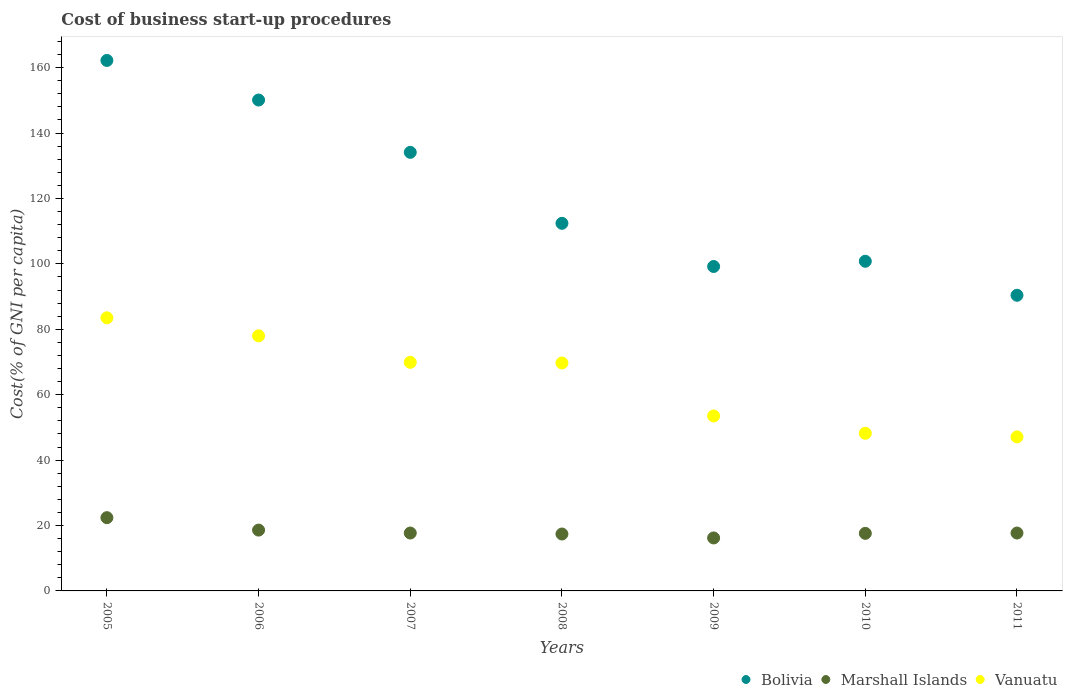Is the number of dotlines equal to the number of legend labels?
Make the answer very short. Yes. What is the cost of business start-up procedures in Bolivia in 2006?
Make the answer very short. 150.1. Across all years, what is the maximum cost of business start-up procedures in Marshall Islands?
Keep it short and to the point. 22.4. Across all years, what is the minimum cost of business start-up procedures in Vanuatu?
Provide a succinct answer. 47.1. What is the total cost of business start-up procedures in Bolivia in the graph?
Offer a very short reply. 849.2. What is the difference between the cost of business start-up procedures in Marshall Islands in 2007 and that in 2010?
Make the answer very short. 0.1. What is the difference between the cost of business start-up procedures in Marshall Islands in 2007 and the cost of business start-up procedures in Vanuatu in 2008?
Provide a short and direct response. -52. What is the average cost of business start-up procedures in Bolivia per year?
Your answer should be compact. 121.31. In the year 2007, what is the difference between the cost of business start-up procedures in Vanuatu and cost of business start-up procedures in Marshall Islands?
Offer a very short reply. 52.2. What is the ratio of the cost of business start-up procedures in Bolivia in 2010 to that in 2011?
Your answer should be compact. 1.12. What is the difference between the highest and the lowest cost of business start-up procedures in Marshall Islands?
Ensure brevity in your answer.  6.2. In how many years, is the cost of business start-up procedures in Vanuatu greater than the average cost of business start-up procedures in Vanuatu taken over all years?
Keep it short and to the point. 4. Is the sum of the cost of business start-up procedures in Marshall Islands in 2005 and 2008 greater than the maximum cost of business start-up procedures in Vanuatu across all years?
Your answer should be very brief. No. Does the cost of business start-up procedures in Marshall Islands monotonically increase over the years?
Give a very brief answer. No. Is the cost of business start-up procedures in Marshall Islands strictly greater than the cost of business start-up procedures in Vanuatu over the years?
Make the answer very short. No. Is the cost of business start-up procedures in Marshall Islands strictly less than the cost of business start-up procedures in Vanuatu over the years?
Offer a terse response. Yes. How many years are there in the graph?
Make the answer very short. 7. Are the values on the major ticks of Y-axis written in scientific E-notation?
Your answer should be compact. No. Does the graph contain grids?
Offer a terse response. No. Where does the legend appear in the graph?
Offer a very short reply. Bottom right. What is the title of the graph?
Offer a terse response. Cost of business start-up procedures. Does "Belarus" appear as one of the legend labels in the graph?
Keep it short and to the point. No. What is the label or title of the Y-axis?
Your response must be concise. Cost(% of GNI per capita). What is the Cost(% of GNI per capita) in Bolivia in 2005?
Ensure brevity in your answer.  162.2. What is the Cost(% of GNI per capita) in Marshall Islands in 2005?
Offer a very short reply. 22.4. What is the Cost(% of GNI per capita) in Vanuatu in 2005?
Ensure brevity in your answer.  83.5. What is the Cost(% of GNI per capita) of Bolivia in 2006?
Give a very brief answer. 150.1. What is the Cost(% of GNI per capita) of Marshall Islands in 2006?
Your answer should be very brief. 18.6. What is the Cost(% of GNI per capita) of Bolivia in 2007?
Give a very brief answer. 134.1. What is the Cost(% of GNI per capita) in Vanuatu in 2007?
Offer a very short reply. 69.9. What is the Cost(% of GNI per capita) of Bolivia in 2008?
Give a very brief answer. 112.4. What is the Cost(% of GNI per capita) in Marshall Islands in 2008?
Your answer should be compact. 17.4. What is the Cost(% of GNI per capita) in Vanuatu in 2008?
Ensure brevity in your answer.  69.7. What is the Cost(% of GNI per capita) of Bolivia in 2009?
Provide a succinct answer. 99.2. What is the Cost(% of GNI per capita) of Vanuatu in 2009?
Offer a very short reply. 53.5. What is the Cost(% of GNI per capita) in Bolivia in 2010?
Provide a short and direct response. 100.8. What is the Cost(% of GNI per capita) in Marshall Islands in 2010?
Make the answer very short. 17.6. What is the Cost(% of GNI per capita) in Vanuatu in 2010?
Offer a very short reply. 48.2. What is the Cost(% of GNI per capita) in Bolivia in 2011?
Keep it short and to the point. 90.4. What is the Cost(% of GNI per capita) of Vanuatu in 2011?
Offer a very short reply. 47.1. Across all years, what is the maximum Cost(% of GNI per capita) in Bolivia?
Give a very brief answer. 162.2. Across all years, what is the maximum Cost(% of GNI per capita) in Marshall Islands?
Give a very brief answer. 22.4. Across all years, what is the maximum Cost(% of GNI per capita) of Vanuatu?
Keep it short and to the point. 83.5. Across all years, what is the minimum Cost(% of GNI per capita) in Bolivia?
Provide a succinct answer. 90.4. Across all years, what is the minimum Cost(% of GNI per capita) of Marshall Islands?
Keep it short and to the point. 16.2. Across all years, what is the minimum Cost(% of GNI per capita) in Vanuatu?
Your answer should be very brief. 47.1. What is the total Cost(% of GNI per capita) of Bolivia in the graph?
Offer a very short reply. 849.2. What is the total Cost(% of GNI per capita) of Marshall Islands in the graph?
Your answer should be compact. 127.6. What is the total Cost(% of GNI per capita) of Vanuatu in the graph?
Ensure brevity in your answer.  449.9. What is the difference between the Cost(% of GNI per capita) in Bolivia in 2005 and that in 2006?
Give a very brief answer. 12.1. What is the difference between the Cost(% of GNI per capita) of Marshall Islands in 2005 and that in 2006?
Provide a short and direct response. 3.8. What is the difference between the Cost(% of GNI per capita) of Bolivia in 2005 and that in 2007?
Keep it short and to the point. 28.1. What is the difference between the Cost(% of GNI per capita) of Bolivia in 2005 and that in 2008?
Provide a short and direct response. 49.8. What is the difference between the Cost(% of GNI per capita) of Marshall Islands in 2005 and that in 2008?
Provide a succinct answer. 5. What is the difference between the Cost(% of GNI per capita) in Bolivia in 2005 and that in 2010?
Provide a succinct answer. 61.4. What is the difference between the Cost(% of GNI per capita) in Marshall Islands in 2005 and that in 2010?
Offer a very short reply. 4.8. What is the difference between the Cost(% of GNI per capita) of Vanuatu in 2005 and that in 2010?
Keep it short and to the point. 35.3. What is the difference between the Cost(% of GNI per capita) in Bolivia in 2005 and that in 2011?
Offer a very short reply. 71.8. What is the difference between the Cost(% of GNI per capita) in Marshall Islands in 2005 and that in 2011?
Your answer should be compact. 4.7. What is the difference between the Cost(% of GNI per capita) in Vanuatu in 2005 and that in 2011?
Give a very brief answer. 36.4. What is the difference between the Cost(% of GNI per capita) in Bolivia in 2006 and that in 2007?
Provide a succinct answer. 16. What is the difference between the Cost(% of GNI per capita) in Vanuatu in 2006 and that in 2007?
Your answer should be very brief. 8.1. What is the difference between the Cost(% of GNI per capita) of Bolivia in 2006 and that in 2008?
Ensure brevity in your answer.  37.7. What is the difference between the Cost(% of GNI per capita) in Marshall Islands in 2006 and that in 2008?
Make the answer very short. 1.2. What is the difference between the Cost(% of GNI per capita) in Bolivia in 2006 and that in 2009?
Offer a terse response. 50.9. What is the difference between the Cost(% of GNI per capita) of Bolivia in 2006 and that in 2010?
Ensure brevity in your answer.  49.3. What is the difference between the Cost(% of GNI per capita) in Marshall Islands in 2006 and that in 2010?
Make the answer very short. 1. What is the difference between the Cost(% of GNI per capita) in Vanuatu in 2006 and that in 2010?
Your response must be concise. 29.8. What is the difference between the Cost(% of GNI per capita) in Bolivia in 2006 and that in 2011?
Your response must be concise. 59.7. What is the difference between the Cost(% of GNI per capita) of Marshall Islands in 2006 and that in 2011?
Make the answer very short. 0.9. What is the difference between the Cost(% of GNI per capita) in Vanuatu in 2006 and that in 2011?
Offer a terse response. 30.9. What is the difference between the Cost(% of GNI per capita) of Bolivia in 2007 and that in 2008?
Provide a short and direct response. 21.7. What is the difference between the Cost(% of GNI per capita) of Marshall Islands in 2007 and that in 2008?
Give a very brief answer. 0.3. What is the difference between the Cost(% of GNI per capita) of Vanuatu in 2007 and that in 2008?
Offer a very short reply. 0.2. What is the difference between the Cost(% of GNI per capita) in Bolivia in 2007 and that in 2009?
Offer a terse response. 34.9. What is the difference between the Cost(% of GNI per capita) of Bolivia in 2007 and that in 2010?
Offer a terse response. 33.3. What is the difference between the Cost(% of GNI per capita) of Vanuatu in 2007 and that in 2010?
Make the answer very short. 21.7. What is the difference between the Cost(% of GNI per capita) in Bolivia in 2007 and that in 2011?
Keep it short and to the point. 43.7. What is the difference between the Cost(% of GNI per capita) in Vanuatu in 2007 and that in 2011?
Your answer should be very brief. 22.8. What is the difference between the Cost(% of GNI per capita) of Bolivia in 2008 and that in 2009?
Offer a terse response. 13.2. What is the difference between the Cost(% of GNI per capita) of Vanuatu in 2008 and that in 2010?
Your answer should be compact. 21.5. What is the difference between the Cost(% of GNI per capita) in Bolivia in 2008 and that in 2011?
Your response must be concise. 22. What is the difference between the Cost(% of GNI per capita) of Marshall Islands in 2008 and that in 2011?
Your answer should be compact. -0.3. What is the difference between the Cost(% of GNI per capita) in Vanuatu in 2008 and that in 2011?
Offer a terse response. 22.6. What is the difference between the Cost(% of GNI per capita) of Bolivia in 2009 and that in 2010?
Provide a succinct answer. -1.6. What is the difference between the Cost(% of GNI per capita) in Marshall Islands in 2009 and that in 2010?
Give a very brief answer. -1.4. What is the difference between the Cost(% of GNI per capita) in Vanuatu in 2009 and that in 2010?
Provide a short and direct response. 5.3. What is the difference between the Cost(% of GNI per capita) in Marshall Islands in 2009 and that in 2011?
Ensure brevity in your answer.  -1.5. What is the difference between the Cost(% of GNI per capita) of Vanuatu in 2009 and that in 2011?
Keep it short and to the point. 6.4. What is the difference between the Cost(% of GNI per capita) in Marshall Islands in 2010 and that in 2011?
Make the answer very short. -0.1. What is the difference between the Cost(% of GNI per capita) of Vanuatu in 2010 and that in 2011?
Your response must be concise. 1.1. What is the difference between the Cost(% of GNI per capita) in Bolivia in 2005 and the Cost(% of GNI per capita) in Marshall Islands in 2006?
Your answer should be compact. 143.6. What is the difference between the Cost(% of GNI per capita) in Bolivia in 2005 and the Cost(% of GNI per capita) in Vanuatu in 2006?
Your response must be concise. 84.2. What is the difference between the Cost(% of GNI per capita) in Marshall Islands in 2005 and the Cost(% of GNI per capita) in Vanuatu in 2006?
Ensure brevity in your answer.  -55.6. What is the difference between the Cost(% of GNI per capita) of Bolivia in 2005 and the Cost(% of GNI per capita) of Marshall Islands in 2007?
Your answer should be compact. 144.5. What is the difference between the Cost(% of GNI per capita) in Bolivia in 2005 and the Cost(% of GNI per capita) in Vanuatu in 2007?
Give a very brief answer. 92.3. What is the difference between the Cost(% of GNI per capita) of Marshall Islands in 2005 and the Cost(% of GNI per capita) of Vanuatu in 2007?
Your response must be concise. -47.5. What is the difference between the Cost(% of GNI per capita) in Bolivia in 2005 and the Cost(% of GNI per capita) in Marshall Islands in 2008?
Keep it short and to the point. 144.8. What is the difference between the Cost(% of GNI per capita) of Bolivia in 2005 and the Cost(% of GNI per capita) of Vanuatu in 2008?
Offer a terse response. 92.5. What is the difference between the Cost(% of GNI per capita) in Marshall Islands in 2005 and the Cost(% of GNI per capita) in Vanuatu in 2008?
Ensure brevity in your answer.  -47.3. What is the difference between the Cost(% of GNI per capita) in Bolivia in 2005 and the Cost(% of GNI per capita) in Marshall Islands in 2009?
Offer a very short reply. 146. What is the difference between the Cost(% of GNI per capita) of Bolivia in 2005 and the Cost(% of GNI per capita) of Vanuatu in 2009?
Provide a short and direct response. 108.7. What is the difference between the Cost(% of GNI per capita) of Marshall Islands in 2005 and the Cost(% of GNI per capita) of Vanuatu in 2009?
Provide a short and direct response. -31.1. What is the difference between the Cost(% of GNI per capita) of Bolivia in 2005 and the Cost(% of GNI per capita) of Marshall Islands in 2010?
Offer a very short reply. 144.6. What is the difference between the Cost(% of GNI per capita) in Bolivia in 2005 and the Cost(% of GNI per capita) in Vanuatu in 2010?
Ensure brevity in your answer.  114. What is the difference between the Cost(% of GNI per capita) of Marshall Islands in 2005 and the Cost(% of GNI per capita) of Vanuatu in 2010?
Your answer should be compact. -25.8. What is the difference between the Cost(% of GNI per capita) in Bolivia in 2005 and the Cost(% of GNI per capita) in Marshall Islands in 2011?
Provide a short and direct response. 144.5. What is the difference between the Cost(% of GNI per capita) in Bolivia in 2005 and the Cost(% of GNI per capita) in Vanuatu in 2011?
Your answer should be very brief. 115.1. What is the difference between the Cost(% of GNI per capita) in Marshall Islands in 2005 and the Cost(% of GNI per capita) in Vanuatu in 2011?
Provide a succinct answer. -24.7. What is the difference between the Cost(% of GNI per capita) in Bolivia in 2006 and the Cost(% of GNI per capita) in Marshall Islands in 2007?
Your answer should be very brief. 132.4. What is the difference between the Cost(% of GNI per capita) of Bolivia in 2006 and the Cost(% of GNI per capita) of Vanuatu in 2007?
Provide a short and direct response. 80.2. What is the difference between the Cost(% of GNI per capita) of Marshall Islands in 2006 and the Cost(% of GNI per capita) of Vanuatu in 2007?
Keep it short and to the point. -51.3. What is the difference between the Cost(% of GNI per capita) of Bolivia in 2006 and the Cost(% of GNI per capita) of Marshall Islands in 2008?
Offer a very short reply. 132.7. What is the difference between the Cost(% of GNI per capita) in Bolivia in 2006 and the Cost(% of GNI per capita) in Vanuatu in 2008?
Offer a terse response. 80.4. What is the difference between the Cost(% of GNI per capita) in Marshall Islands in 2006 and the Cost(% of GNI per capita) in Vanuatu in 2008?
Your response must be concise. -51.1. What is the difference between the Cost(% of GNI per capita) in Bolivia in 2006 and the Cost(% of GNI per capita) in Marshall Islands in 2009?
Your answer should be compact. 133.9. What is the difference between the Cost(% of GNI per capita) in Bolivia in 2006 and the Cost(% of GNI per capita) in Vanuatu in 2009?
Your answer should be compact. 96.6. What is the difference between the Cost(% of GNI per capita) of Marshall Islands in 2006 and the Cost(% of GNI per capita) of Vanuatu in 2009?
Offer a very short reply. -34.9. What is the difference between the Cost(% of GNI per capita) of Bolivia in 2006 and the Cost(% of GNI per capita) of Marshall Islands in 2010?
Keep it short and to the point. 132.5. What is the difference between the Cost(% of GNI per capita) of Bolivia in 2006 and the Cost(% of GNI per capita) of Vanuatu in 2010?
Your answer should be compact. 101.9. What is the difference between the Cost(% of GNI per capita) of Marshall Islands in 2006 and the Cost(% of GNI per capita) of Vanuatu in 2010?
Keep it short and to the point. -29.6. What is the difference between the Cost(% of GNI per capita) in Bolivia in 2006 and the Cost(% of GNI per capita) in Marshall Islands in 2011?
Your response must be concise. 132.4. What is the difference between the Cost(% of GNI per capita) in Bolivia in 2006 and the Cost(% of GNI per capita) in Vanuatu in 2011?
Provide a succinct answer. 103. What is the difference between the Cost(% of GNI per capita) of Marshall Islands in 2006 and the Cost(% of GNI per capita) of Vanuatu in 2011?
Keep it short and to the point. -28.5. What is the difference between the Cost(% of GNI per capita) of Bolivia in 2007 and the Cost(% of GNI per capita) of Marshall Islands in 2008?
Your response must be concise. 116.7. What is the difference between the Cost(% of GNI per capita) of Bolivia in 2007 and the Cost(% of GNI per capita) of Vanuatu in 2008?
Offer a terse response. 64.4. What is the difference between the Cost(% of GNI per capita) of Marshall Islands in 2007 and the Cost(% of GNI per capita) of Vanuatu in 2008?
Your answer should be compact. -52. What is the difference between the Cost(% of GNI per capita) in Bolivia in 2007 and the Cost(% of GNI per capita) in Marshall Islands in 2009?
Your response must be concise. 117.9. What is the difference between the Cost(% of GNI per capita) in Bolivia in 2007 and the Cost(% of GNI per capita) in Vanuatu in 2009?
Provide a short and direct response. 80.6. What is the difference between the Cost(% of GNI per capita) in Marshall Islands in 2007 and the Cost(% of GNI per capita) in Vanuatu in 2009?
Keep it short and to the point. -35.8. What is the difference between the Cost(% of GNI per capita) of Bolivia in 2007 and the Cost(% of GNI per capita) of Marshall Islands in 2010?
Make the answer very short. 116.5. What is the difference between the Cost(% of GNI per capita) of Bolivia in 2007 and the Cost(% of GNI per capita) of Vanuatu in 2010?
Your answer should be very brief. 85.9. What is the difference between the Cost(% of GNI per capita) of Marshall Islands in 2007 and the Cost(% of GNI per capita) of Vanuatu in 2010?
Provide a succinct answer. -30.5. What is the difference between the Cost(% of GNI per capita) in Bolivia in 2007 and the Cost(% of GNI per capita) in Marshall Islands in 2011?
Keep it short and to the point. 116.4. What is the difference between the Cost(% of GNI per capita) of Bolivia in 2007 and the Cost(% of GNI per capita) of Vanuatu in 2011?
Provide a short and direct response. 87. What is the difference between the Cost(% of GNI per capita) in Marshall Islands in 2007 and the Cost(% of GNI per capita) in Vanuatu in 2011?
Keep it short and to the point. -29.4. What is the difference between the Cost(% of GNI per capita) of Bolivia in 2008 and the Cost(% of GNI per capita) of Marshall Islands in 2009?
Offer a terse response. 96.2. What is the difference between the Cost(% of GNI per capita) of Bolivia in 2008 and the Cost(% of GNI per capita) of Vanuatu in 2009?
Keep it short and to the point. 58.9. What is the difference between the Cost(% of GNI per capita) of Marshall Islands in 2008 and the Cost(% of GNI per capita) of Vanuatu in 2009?
Your answer should be very brief. -36.1. What is the difference between the Cost(% of GNI per capita) of Bolivia in 2008 and the Cost(% of GNI per capita) of Marshall Islands in 2010?
Provide a succinct answer. 94.8. What is the difference between the Cost(% of GNI per capita) in Bolivia in 2008 and the Cost(% of GNI per capita) in Vanuatu in 2010?
Give a very brief answer. 64.2. What is the difference between the Cost(% of GNI per capita) of Marshall Islands in 2008 and the Cost(% of GNI per capita) of Vanuatu in 2010?
Give a very brief answer. -30.8. What is the difference between the Cost(% of GNI per capita) of Bolivia in 2008 and the Cost(% of GNI per capita) of Marshall Islands in 2011?
Provide a succinct answer. 94.7. What is the difference between the Cost(% of GNI per capita) in Bolivia in 2008 and the Cost(% of GNI per capita) in Vanuatu in 2011?
Provide a short and direct response. 65.3. What is the difference between the Cost(% of GNI per capita) in Marshall Islands in 2008 and the Cost(% of GNI per capita) in Vanuatu in 2011?
Your response must be concise. -29.7. What is the difference between the Cost(% of GNI per capita) in Bolivia in 2009 and the Cost(% of GNI per capita) in Marshall Islands in 2010?
Your answer should be very brief. 81.6. What is the difference between the Cost(% of GNI per capita) in Bolivia in 2009 and the Cost(% of GNI per capita) in Vanuatu in 2010?
Offer a very short reply. 51. What is the difference between the Cost(% of GNI per capita) in Marshall Islands in 2009 and the Cost(% of GNI per capita) in Vanuatu in 2010?
Your response must be concise. -32. What is the difference between the Cost(% of GNI per capita) in Bolivia in 2009 and the Cost(% of GNI per capita) in Marshall Islands in 2011?
Your answer should be very brief. 81.5. What is the difference between the Cost(% of GNI per capita) of Bolivia in 2009 and the Cost(% of GNI per capita) of Vanuatu in 2011?
Offer a terse response. 52.1. What is the difference between the Cost(% of GNI per capita) in Marshall Islands in 2009 and the Cost(% of GNI per capita) in Vanuatu in 2011?
Offer a very short reply. -30.9. What is the difference between the Cost(% of GNI per capita) in Bolivia in 2010 and the Cost(% of GNI per capita) in Marshall Islands in 2011?
Provide a succinct answer. 83.1. What is the difference between the Cost(% of GNI per capita) in Bolivia in 2010 and the Cost(% of GNI per capita) in Vanuatu in 2011?
Provide a short and direct response. 53.7. What is the difference between the Cost(% of GNI per capita) of Marshall Islands in 2010 and the Cost(% of GNI per capita) of Vanuatu in 2011?
Ensure brevity in your answer.  -29.5. What is the average Cost(% of GNI per capita) in Bolivia per year?
Your response must be concise. 121.31. What is the average Cost(% of GNI per capita) of Marshall Islands per year?
Provide a short and direct response. 18.23. What is the average Cost(% of GNI per capita) in Vanuatu per year?
Ensure brevity in your answer.  64.27. In the year 2005, what is the difference between the Cost(% of GNI per capita) of Bolivia and Cost(% of GNI per capita) of Marshall Islands?
Offer a very short reply. 139.8. In the year 2005, what is the difference between the Cost(% of GNI per capita) in Bolivia and Cost(% of GNI per capita) in Vanuatu?
Make the answer very short. 78.7. In the year 2005, what is the difference between the Cost(% of GNI per capita) of Marshall Islands and Cost(% of GNI per capita) of Vanuatu?
Make the answer very short. -61.1. In the year 2006, what is the difference between the Cost(% of GNI per capita) in Bolivia and Cost(% of GNI per capita) in Marshall Islands?
Offer a very short reply. 131.5. In the year 2006, what is the difference between the Cost(% of GNI per capita) of Bolivia and Cost(% of GNI per capita) of Vanuatu?
Ensure brevity in your answer.  72.1. In the year 2006, what is the difference between the Cost(% of GNI per capita) in Marshall Islands and Cost(% of GNI per capita) in Vanuatu?
Your answer should be compact. -59.4. In the year 2007, what is the difference between the Cost(% of GNI per capita) in Bolivia and Cost(% of GNI per capita) in Marshall Islands?
Offer a very short reply. 116.4. In the year 2007, what is the difference between the Cost(% of GNI per capita) in Bolivia and Cost(% of GNI per capita) in Vanuatu?
Keep it short and to the point. 64.2. In the year 2007, what is the difference between the Cost(% of GNI per capita) of Marshall Islands and Cost(% of GNI per capita) of Vanuatu?
Your response must be concise. -52.2. In the year 2008, what is the difference between the Cost(% of GNI per capita) in Bolivia and Cost(% of GNI per capita) in Vanuatu?
Keep it short and to the point. 42.7. In the year 2008, what is the difference between the Cost(% of GNI per capita) in Marshall Islands and Cost(% of GNI per capita) in Vanuatu?
Give a very brief answer. -52.3. In the year 2009, what is the difference between the Cost(% of GNI per capita) in Bolivia and Cost(% of GNI per capita) in Marshall Islands?
Offer a terse response. 83. In the year 2009, what is the difference between the Cost(% of GNI per capita) in Bolivia and Cost(% of GNI per capita) in Vanuatu?
Provide a succinct answer. 45.7. In the year 2009, what is the difference between the Cost(% of GNI per capita) of Marshall Islands and Cost(% of GNI per capita) of Vanuatu?
Provide a short and direct response. -37.3. In the year 2010, what is the difference between the Cost(% of GNI per capita) of Bolivia and Cost(% of GNI per capita) of Marshall Islands?
Your response must be concise. 83.2. In the year 2010, what is the difference between the Cost(% of GNI per capita) in Bolivia and Cost(% of GNI per capita) in Vanuatu?
Provide a short and direct response. 52.6. In the year 2010, what is the difference between the Cost(% of GNI per capita) in Marshall Islands and Cost(% of GNI per capita) in Vanuatu?
Provide a short and direct response. -30.6. In the year 2011, what is the difference between the Cost(% of GNI per capita) in Bolivia and Cost(% of GNI per capita) in Marshall Islands?
Keep it short and to the point. 72.7. In the year 2011, what is the difference between the Cost(% of GNI per capita) in Bolivia and Cost(% of GNI per capita) in Vanuatu?
Ensure brevity in your answer.  43.3. In the year 2011, what is the difference between the Cost(% of GNI per capita) in Marshall Islands and Cost(% of GNI per capita) in Vanuatu?
Provide a short and direct response. -29.4. What is the ratio of the Cost(% of GNI per capita) of Bolivia in 2005 to that in 2006?
Keep it short and to the point. 1.08. What is the ratio of the Cost(% of GNI per capita) of Marshall Islands in 2005 to that in 2006?
Offer a very short reply. 1.2. What is the ratio of the Cost(% of GNI per capita) in Vanuatu in 2005 to that in 2006?
Provide a succinct answer. 1.07. What is the ratio of the Cost(% of GNI per capita) in Bolivia in 2005 to that in 2007?
Provide a short and direct response. 1.21. What is the ratio of the Cost(% of GNI per capita) of Marshall Islands in 2005 to that in 2007?
Your answer should be compact. 1.27. What is the ratio of the Cost(% of GNI per capita) in Vanuatu in 2005 to that in 2007?
Your response must be concise. 1.19. What is the ratio of the Cost(% of GNI per capita) of Bolivia in 2005 to that in 2008?
Offer a terse response. 1.44. What is the ratio of the Cost(% of GNI per capita) of Marshall Islands in 2005 to that in 2008?
Make the answer very short. 1.29. What is the ratio of the Cost(% of GNI per capita) in Vanuatu in 2005 to that in 2008?
Keep it short and to the point. 1.2. What is the ratio of the Cost(% of GNI per capita) of Bolivia in 2005 to that in 2009?
Your response must be concise. 1.64. What is the ratio of the Cost(% of GNI per capita) of Marshall Islands in 2005 to that in 2009?
Provide a succinct answer. 1.38. What is the ratio of the Cost(% of GNI per capita) in Vanuatu in 2005 to that in 2009?
Ensure brevity in your answer.  1.56. What is the ratio of the Cost(% of GNI per capita) in Bolivia in 2005 to that in 2010?
Your response must be concise. 1.61. What is the ratio of the Cost(% of GNI per capita) in Marshall Islands in 2005 to that in 2010?
Make the answer very short. 1.27. What is the ratio of the Cost(% of GNI per capita) in Vanuatu in 2005 to that in 2010?
Offer a very short reply. 1.73. What is the ratio of the Cost(% of GNI per capita) in Bolivia in 2005 to that in 2011?
Provide a short and direct response. 1.79. What is the ratio of the Cost(% of GNI per capita) of Marshall Islands in 2005 to that in 2011?
Your answer should be very brief. 1.27. What is the ratio of the Cost(% of GNI per capita) of Vanuatu in 2005 to that in 2011?
Keep it short and to the point. 1.77. What is the ratio of the Cost(% of GNI per capita) of Bolivia in 2006 to that in 2007?
Ensure brevity in your answer.  1.12. What is the ratio of the Cost(% of GNI per capita) of Marshall Islands in 2006 to that in 2007?
Make the answer very short. 1.05. What is the ratio of the Cost(% of GNI per capita) in Vanuatu in 2006 to that in 2007?
Offer a very short reply. 1.12. What is the ratio of the Cost(% of GNI per capita) of Bolivia in 2006 to that in 2008?
Make the answer very short. 1.34. What is the ratio of the Cost(% of GNI per capita) of Marshall Islands in 2006 to that in 2008?
Make the answer very short. 1.07. What is the ratio of the Cost(% of GNI per capita) in Vanuatu in 2006 to that in 2008?
Your answer should be compact. 1.12. What is the ratio of the Cost(% of GNI per capita) in Bolivia in 2006 to that in 2009?
Your answer should be very brief. 1.51. What is the ratio of the Cost(% of GNI per capita) of Marshall Islands in 2006 to that in 2009?
Keep it short and to the point. 1.15. What is the ratio of the Cost(% of GNI per capita) in Vanuatu in 2006 to that in 2009?
Provide a succinct answer. 1.46. What is the ratio of the Cost(% of GNI per capita) in Bolivia in 2006 to that in 2010?
Provide a succinct answer. 1.49. What is the ratio of the Cost(% of GNI per capita) in Marshall Islands in 2006 to that in 2010?
Your answer should be very brief. 1.06. What is the ratio of the Cost(% of GNI per capita) in Vanuatu in 2006 to that in 2010?
Offer a very short reply. 1.62. What is the ratio of the Cost(% of GNI per capita) in Bolivia in 2006 to that in 2011?
Provide a short and direct response. 1.66. What is the ratio of the Cost(% of GNI per capita) of Marshall Islands in 2006 to that in 2011?
Your answer should be very brief. 1.05. What is the ratio of the Cost(% of GNI per capita) of Vanuatu in 2006 to that in 2011?
Give a very brief answer. 1.66. What is the ratio of the Cost(% of GNI per capita) in Bolivia in 2007 to that in 2008?
Your answer should be very brief. 1.19. What is the ratio of the Cost(% of GNI per capita) in Marshall Islands in 2007 to that in 2008?
Your answer should be very brief. 1.02. What is the ratio of the Cost(% of GNI per capita) of Bolivia in 2007 to that in 2009?
Your response must be concise. 1.35. What is the ratio of the Cost(% of GNI per capita) in Marshall Islands in 2007 to that in 2009?
Provide a short and direct response. 1.09. What is the ratio of the Cost(% of GNI per capita) in Vanuatu in 2007 to that in 2009?
Offer a very short reply. 1.31. What is the ratio of the Cost(% of GNI per capita) of Bolivia in 2007 to that in 2010?
Give a very brief answer. 1.33. What is the ratio of the Cost(% of GNI per capita) in Vanuatu in 2007 to that in 2010?
Keep it short and to the point. 1.45. What is the ratio of the Cost(% of GNI per capita) in Bolivia in 2007 to that in 2011?
Keep it short and to the point. 1.48. What is the ratio of the Cost(% of GNI per capita) of Marshall Islands in 2007 to that in 2011?
Your response must be concise. 1. What is the ratio of the Cost(% of GNI per capita) in Vanuatu in 2007 to that in 2011?
Keep it short and to the point. 1.48. What is the ratio of the Cost(% of GNI per capita) of Bolivia in 2008 to that in 2009?
Your response must be concise. 1.13. What is the ratio of the Cost(% of GNI per capita) in Marshall Islands in 2008 to that in 2009?
Provide a succinct answer. 1.07. What is the ratio of the Cost(% of GNI per capita) of Vanuatu in 2008 to that in 2009?
Give a very brief answer. 1.3. What is the ratio of the Cost(% of GNI per capita) in Bolivia in 2008 to that in 2010?
Give a very brief answer. 1.12. What is the ratio of the Cost(% of GNI per capita) in Vanuatu in 2008 to that in 2010?
Your response must be concise. 1.45. What is the ratio of the Cost(% of GNI per capita) in Bolivia in 2008 to that in 2011?
Give a very brief answer. 1.24. What is the ratio of the Cost(% of GNI per capita) of Marshall Islands in 2008 to that in 2011?
Offer a terse response. 0.98. What is the ratio of the Cost(% of GNI per capita) in Vanuatu in 2008 to that in 2011?
Provide a succinct answer. 1.48. What is the ratio of the Cost(% of GNI per capita) of Bolivia in 2009 to that in 2010?
Your response must be concise. 0.98. What is the ratio of the Cost(% of GNI per capita) in Marshall Islands in 2009 to that in 2010?
Offer a terse response. 0.92. What is the ratio of the Cost(% of GNI per capita) of Vanuatu in 2009 to that in 2010?
Keep it short and to the point. 1.11. What is the ratio of the Cost(% of GNI per capita) of Bolivia in 2009 to that in 2011?
Your response must be concise. 1.1. What is the ratio of the Cost(% of GNI per capita) in Marshall Islands in 2009 to that in 2011?
Provide a succinct answer. 0.92. What is the ratio of the Cost(% of GNI per capita) of Vanuatu in 2009 to that in 2011?
Your answer should be very brief. 1.14. What is the ratio of the Cost(% of GNI per capita) of Bolivia in 2010 to that in 2011?
Offer a terse response. 1.11. What is the ratio of the Cost(% of GNI per capita) of Marshall Islands in 2010 to that in 2011?
Offer a terse response. 0.99. What is the ratio of the Cost(% of GNI per capita) in Vanuatu in 2010 to that in 2011?
Your answer should be very brief. 1.02. What is the difference between the highest and the lowest Cost(% of GNI per capita) in Bolivia?
Provide a short and direct response. 71.8. What is the difference between the highest and the lowest Cost(% of GNI per capita) of Marshall Islands?
Provide a succinct answer. 6.2. What is the difference between the highest and the lowest Cost(% of GNI per capita) in Vanuatu?
Offer a very short reply. 36.4. 